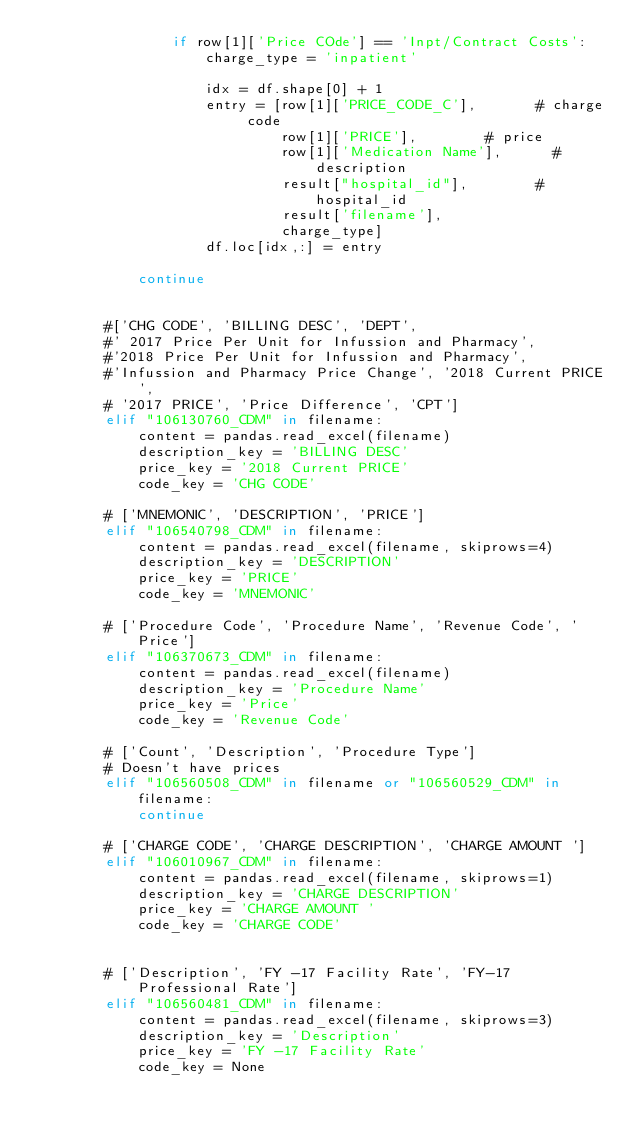<code> <loc_0><loc_0><loc_500><loc_500><_Python_>                if row[1]['Price COde'] == 'Inpt/Contract Costs':
                    charge_type = 'inpatient'

                    idx = df.shape[0] + 1
                    entry = [row[1]['PRICE_CODE_C'],       # charge code
                             row[1]['PRICE'],        # price
                             row[1]['Medication Name'],      # description
                             result["hospital_id"],        # hospital_id
                             result['filename'],
                             charge_type]     
                    df.loc[idx,:] = entry

            continue


        #['CHG CODE', 'BILLING DESC', 'DEPT',
        #' 2017 Price Per Unit for Infussion and Pharmacy',
        #'2018 Price Per Unit for Infussion and Pharmacy',
        #'Infussion and Pharmacy Price Change', '2018 Current PRICE',
        # '2017 PRICE', 'Price Difference', 'CPT']
        elif "106130760_CDM" in filename:
            content = pandas.read_excel(filename)
            description_key = 'BILLING DESC'
            price_key = '2018 Current PRICE'
            code_key = 'CHG CODE'

        # ['MNEMONIC', 'DESCRIPTION', 'PRICE']
        elif "106540798_CDM" in filename:
            content = pandas.read_excel(filename, skiprows=4)
            description_key = 'DESCRIPTION'
            price_key = 'PRICE' 
            code_key = 'MNEMONIC'

        # ['Procedure Code', 'Procedure Name', 'Revenue Code', 'Price']
        elif "106370673_CDM" in filename:
            content = pandas.read_excel(filename)
            description_key = 'Procedure Name'
            price_key = 'Price' 
            code_key = 'Revenue Code'

        # ['Count', 'Description', 'Procedure Type']
        # Doesn't have prices
        elif "106560508_CDM" in filename or "106560529_CDM" in filename:
            continue

        # ['CHARGE CODE', 'CHARGE DESCRIPTION', 'CHARGE AMOUNT ']
        elif "106010967_CDM" in filename:
            content = pandas.read_excel(filename, skiprows=1) 
            description_key = 'CHARGE DESCRIPTION'
            price_key = 'CHARGE AMOUNT ' 
            code_key = 'CHARGE CODE'


        # ['Description', 'FY -17 Facility Rate', 'FY-17 Professional Rate']
        elif "106560481_CDM" in filename:
            content = pandas.read_excel(filename, skiprows=3) 
            description_key = 'Description'
            price_key = 'FY -17 Facility Rate'
            code_key = None
</code> 